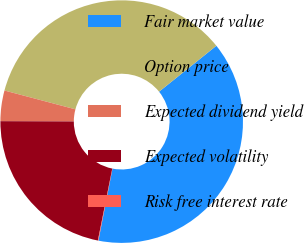<chart> <loc_0><loc_0><loc_500><loc_500><pie_chart><fcel>Fair market value<fcel>Option price<fcel>Expected dividend yield<fcel>Expected volatility<fcel>Risk free interest rate<nl><fcel>38.82%<fcel>35.12%<fcel>4.07%<fcel>21.91%<fcel>0.07%<nl></chart> 